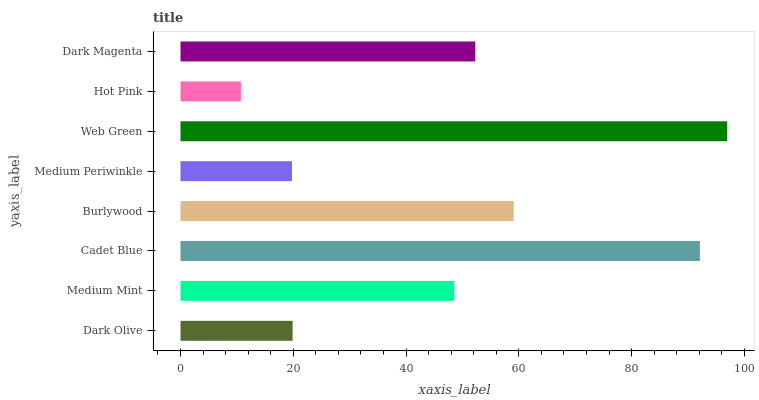Is Hot Pink the minimum?
Answer yes or no. Yes. Is Web Green the maximum?
Answer yes or no. Yes. Is Medium Mint the minimum?
Answer yes or no. No. Is Medium Mint the maximum?
Answer yes or no. No. Is Medium Mint greater than Dark Olive?
Answer yes or no. Yes. Is Dark Olive less than Medium Mint?
Answer yes or no. Yes. Is Dark Olive greater than Medium Mint?
Answer yes or no. No. Is Medium Mint less than Dark Olive?
Answer yes or no. No. Is Dark Magenta the high median?
Answer yes or no. Yes. Is Medium Mint the low median?
Answer yes or no. Yes. Is Medium Periwinkle the high median?
Answer yes or no. No. Is Dark Olive the low median?
Answer yes or no. No. 